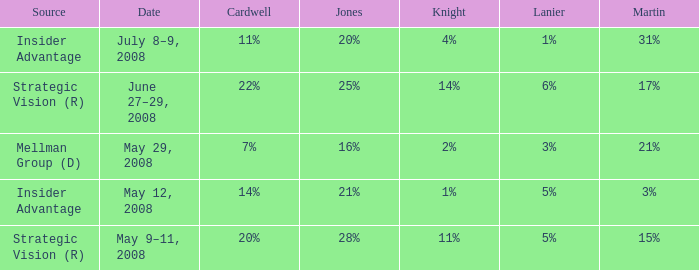What martin is on july 8–9, 2008? 31%. 